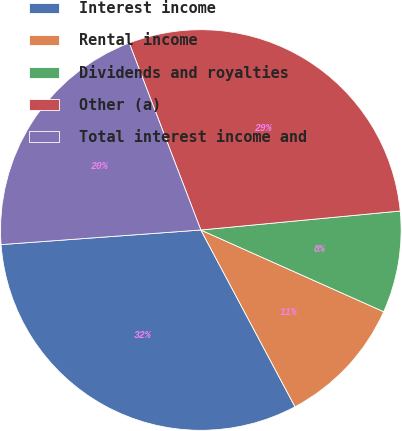Convert chart. <chart><loc_0><loc_0><loc_500><loc_500><pie_chart><fcel>Interest income<fcel>Rental income<fcel>Dividends and royalties<fcel>Other (a)<fcel>Total interest income and<nl><fcel>31.63%<fcel>10.52%<fcel>8.2%<fcel>29.31%<fcel>20.34%<nl></chart> 